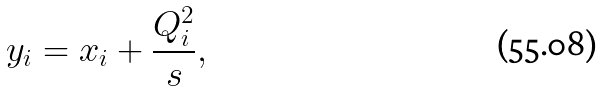Convert formula to latex. <formula><loc_0><loc_0><loc_500><loc_500>y _ { i } = x _ { i } + \frac { Q _ { i } ^ { 2 } } { s } ,</formula> 